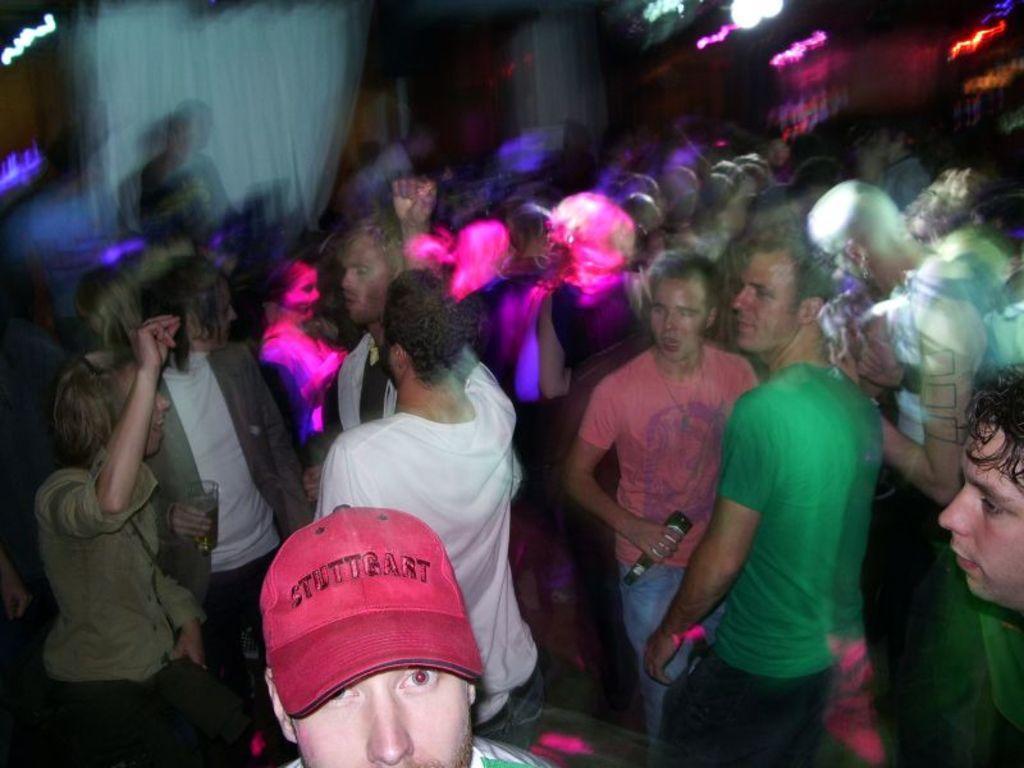Could you give a brief overview of what you see in this image? In the image there are many people dancing all over the place, this seems to be clicked inside a pub, there are lights over the ceiling. 